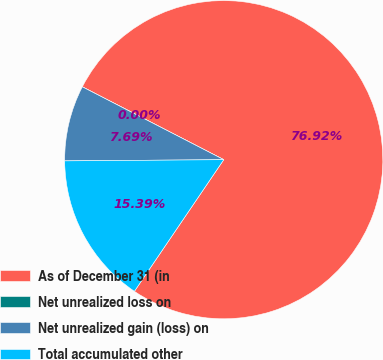Convert chart. <chart><loc_0><loc_0><loc_500><loc_500><pie_chart><fcel>As of December 31 (in<fcel>Net unrealized loss on<fcel>Net unrealized gain (loss) on<fcel>Total accumulated other<nl><fcel>76.92%<fcel>0.0%<fcel>7.69%<fcel>15.39%<nl></chart> 